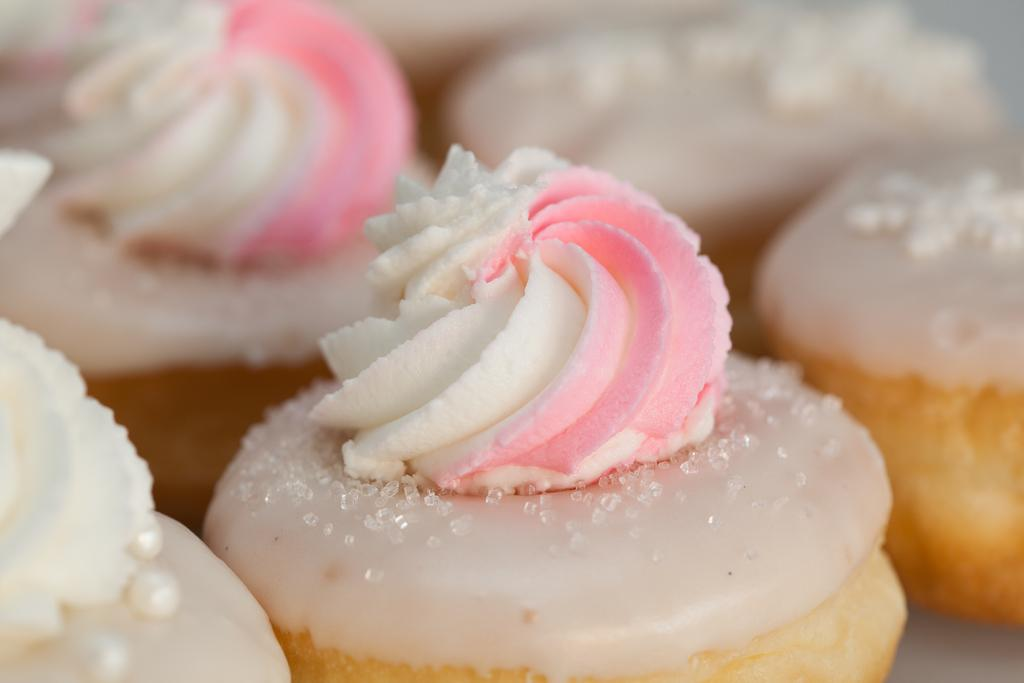What is the main subject of the image? The main subject of the image is food. Can you describe the background of the image? The background of the image is blurry. What type of rhythm can be heard coming from the sofa in the image? There is no sofa or any sound in the image, so it's not possible to determine what rhythm might be heard. 